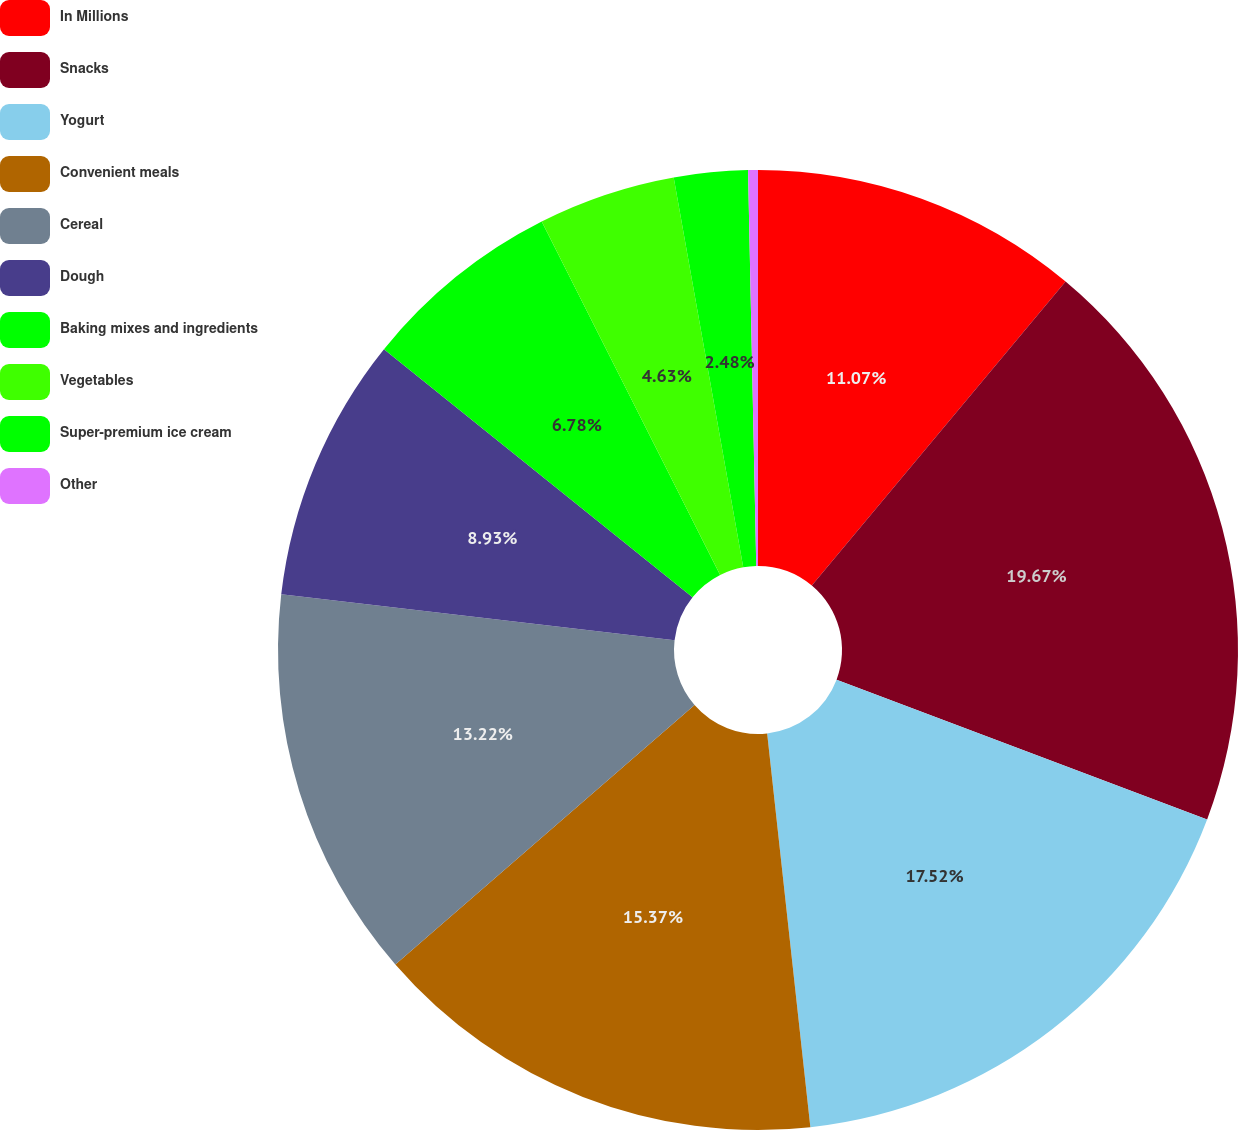Convert chart to OTSL. <chart><loc_0><loc_0><loc_500><loc_500><pie_chart><fcel>In Millions<fcel>Snacks<fcel>Yogurt<fcel>Convenient meals<fcel>Cereal<fcel>Dough<fcel>Baking mixes and ingredients<fcel>Vegetables<fcel>Super-premium ice cream<fcel>Other<nl><fcel>11.07%<fcel>19.67%<fcel>17.52%<fcel>15.37%<fcel>13.22%<fcel>8.93%<fcel>6.78%<fcel>4.63%<fcel>2.48%<fcel>0.33%<nl></chart> 